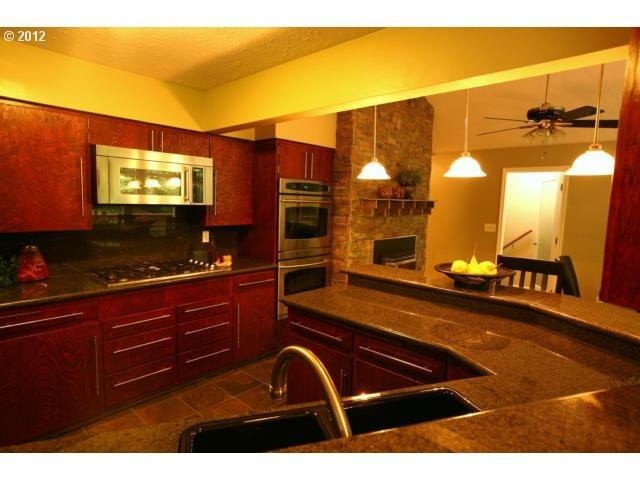Is there a stairwell in this picture?
Answer briefly. Yes. Are there dirty dishes in the sink?
Keep it brief. No. Do all three kitchen lights appear to be on?
Quick response, please. Yes. 